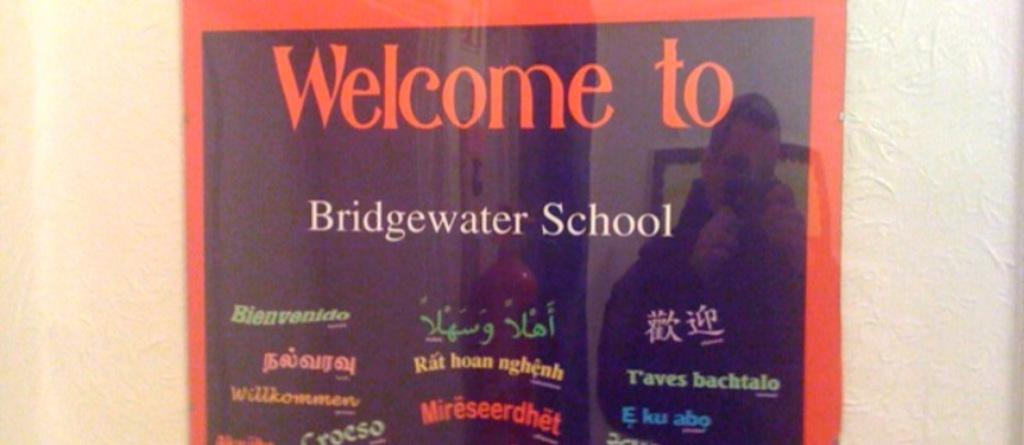<image>
Describe the image concisely. A red and black sign says Welcome to Bridgewater School. 